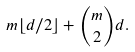Convert formula to latex. <formula><loc_0><loc_0><loc_500><loc_500>m \lfloor d / 2 \rfloor + \binom { m } { 2 } d .</formula> 